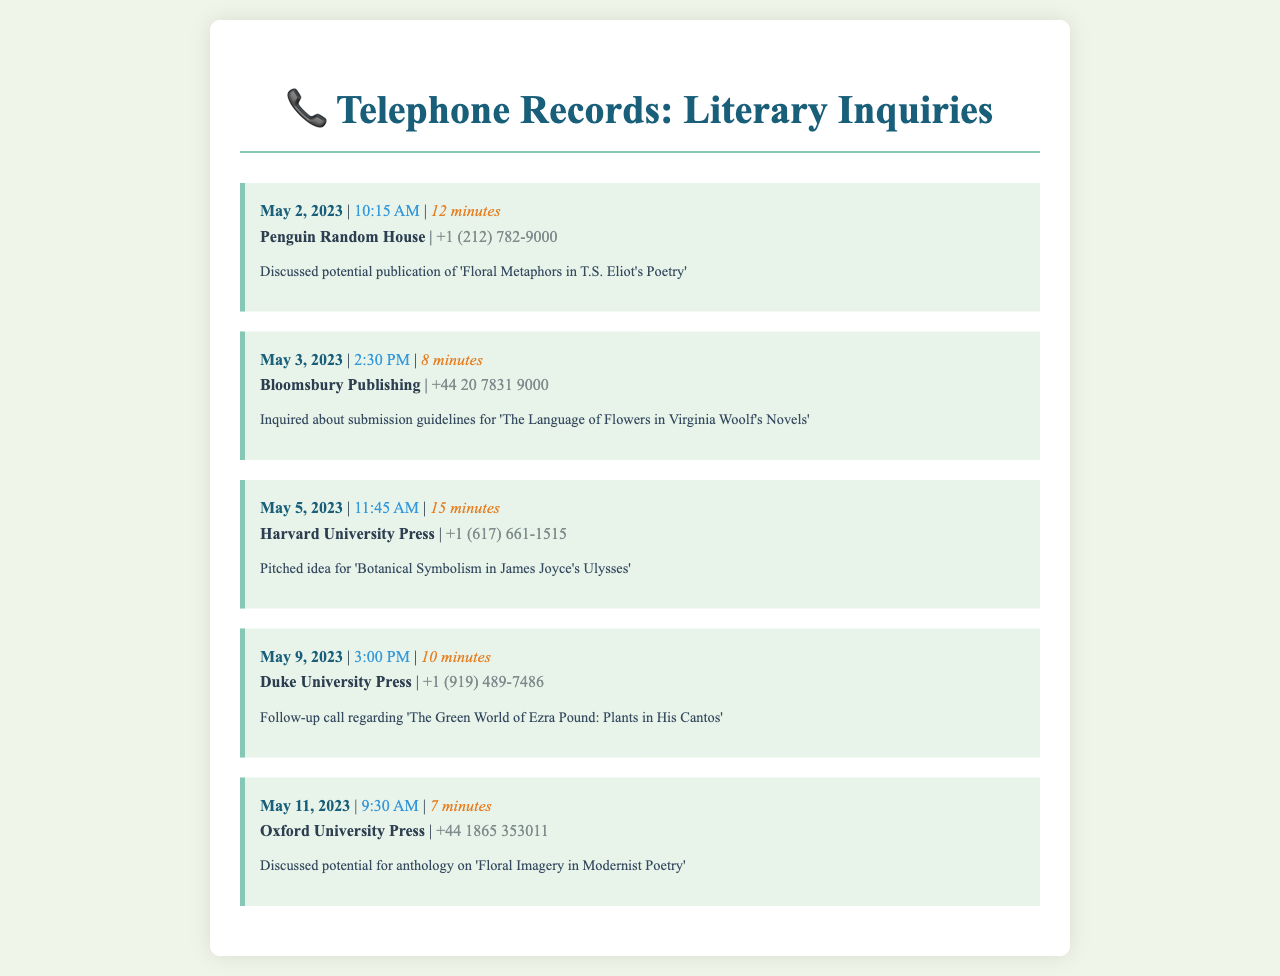What is the first publisher contacted? The first publisher mentioned in the document is Penguin Random House, which was contacted on May 2, 2023.
Answer: Penguin Random House How long was the call to Bloomsbury Publishing? The call duration of the call made to Bloomsbury Publishing on May 3, 2023, is provided in the document.
Answer: 8 minutes What is the title discussed with Harvard University Press? The document states the specific title pitched to Harvard University Press.
Answer: Botanical Symbolism in James Joyce's Ulysses On what date was the follow-up call made to Duke University Press? The date of the follow-up call to Duke University Press is explicitly listed in the document.
Answer: May 9, 2023 Which publisher was contacted on May 11, 2023? The document lists the publisher contacted on this specific date.
Answer: Oxford University Press What was the main topic of the call with Penguin Random House? The document notes the key discussion point for the call with Penguin Random House.
Answer: Publication of 'Floral Metaphors in T.S. Eliot's Poetry' How many calls were made to publishers in total? The document provides detailed records of each call made, which can be counted.
Answer: 5 calls 